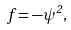<formula> <loc_0><loc_0><loc_500><loc_500>f = - \psi ^ { 2 } ,</formula> 